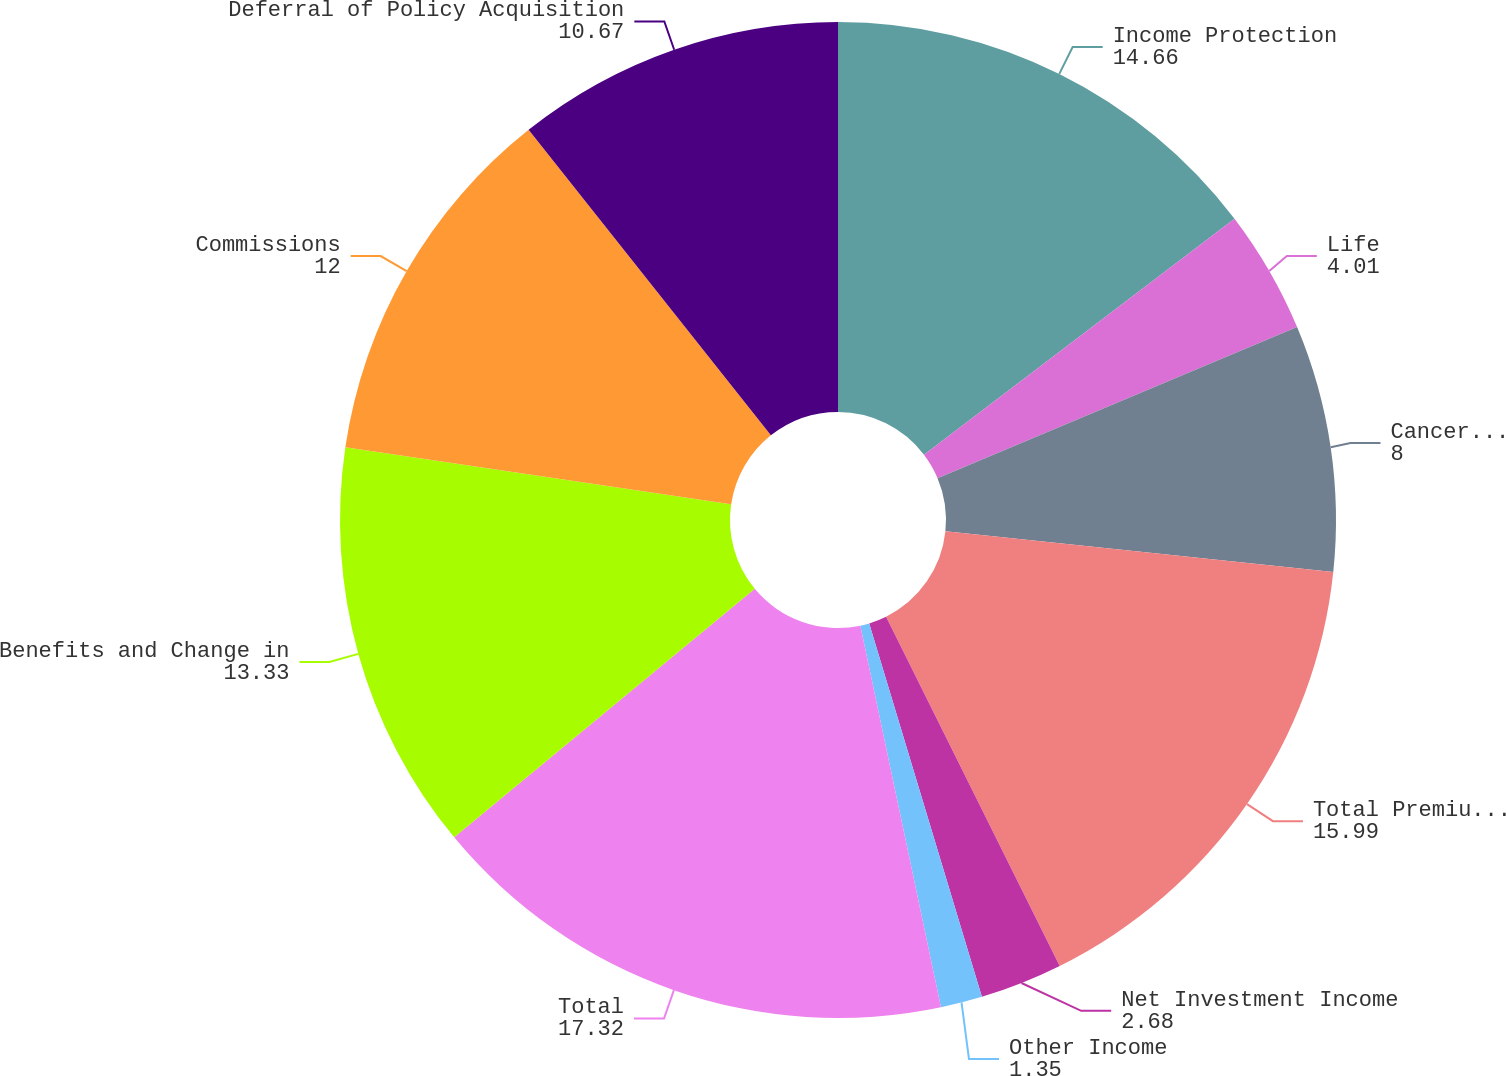Convert chart. <chart><loc_0><loc_0><loc_500><loc_500><pie_chart><fcel>Income Protection<fcel>Life<fcel>Cancer and Critical Illness<fcel>Total Premium Income<fcel>Net Investment Income<fcel>Other Income<fcel>Total<fcel>Benefits and Change in<fcel>Commissions<fcel>Deferral of Policy Acquisition<nl><fcel>14.66%<fcel>4.01%<fcel>8.0%<fcel>15.99%<fcel>2.68%<fcel>1.35%<fcel>17.32%<fcel>13.33%<fcel>12.0%<fcel>10.67%<nl></chart> 